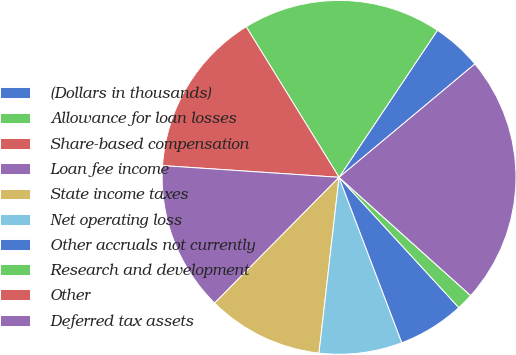Convert chart to OTSL. <chart><loc_0><loc_0><loc_500><loc_500><pie_chart><fcel>(Dollars in thousands)<fcel>Allowance for loan losses<fcel>Share-based compensation<fcel>Loan fee income<fcel>State income taxes<fcel>Net operating loss<fcel>Other accruals not currently<fcel>Research and development<fcel>Other<fcel>Deferred tax assets<nl><fcel>4.55%<fcel>18.18%<fcel>15.15%<fcel>13.64%<fcel>10.61%<fcel>7.58%<fcel>6.06%<fcel>1.52%<fcel>0.0%<fcel>22.72%<nl></chart> 